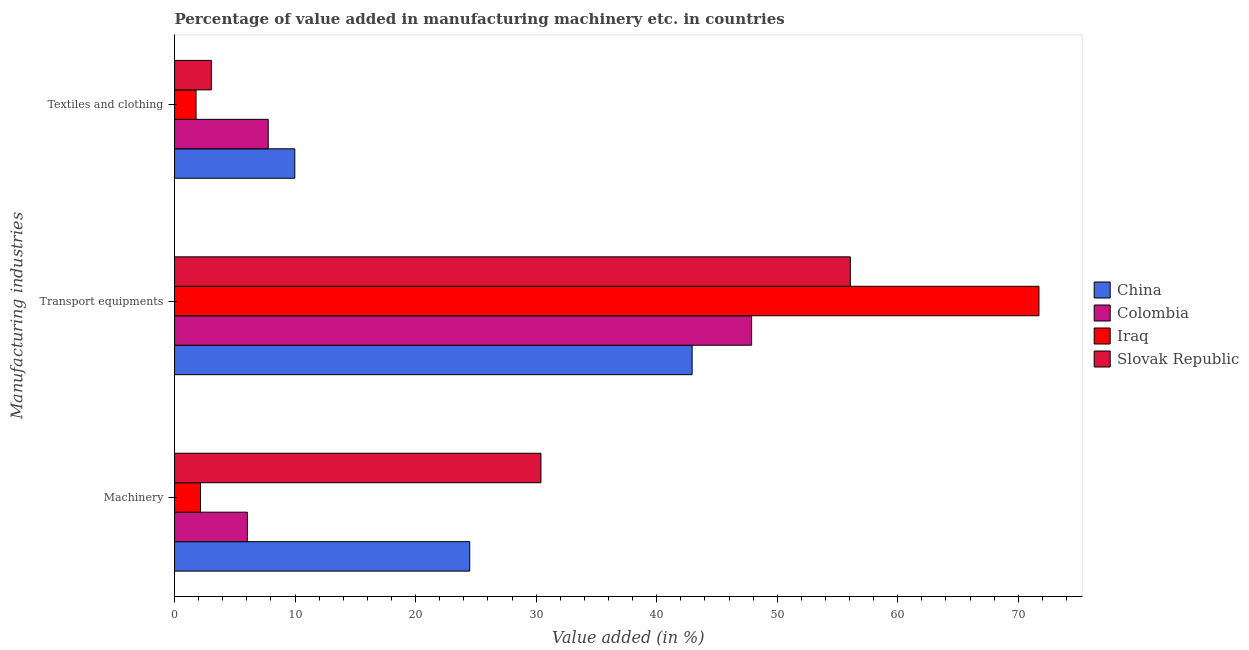How many groups of bars are there?
Your answer should be very brief. 3. Are the number of bars per tick equal to the number of legend labels?
Your answer should be very brief. Yes. How many bars are there on the 2nd tick from the top?
Your answer should be very brief. 4. How many bars are there on the 2nd tick from the bottom?
Your answer should be very brief. 4. What is the label of the 1st group of bars from the top?
Your response must be concise. Textiles and clothing. What is the value added in manufacturing textile and clothing in Iraq?
Keep it short and to the point. 1.78. Across all countries, what is the maximum value added in manufacturing textile and clothing?
Provide a succinct answer. 9.98. Across all countries, what is the minimum value added in manufacturing machinery?
Your response must be concise. 2.15. In which country was the value added in manufacturing textile and clothing maximum?
Give a very brief answer. China. In which country was the value added in manufacturing textile and clothing minimum?
Provide a succinct answer. Iraq. What is the total value added in manufacturing textile and clothing in the graph?
Your response must be concise. 22.58. What is the difference between the value added in manufacturing machinery in Iraq and that in China?
Offer a very short reply. -22.33. What is the difference between the value added in manufacturing machinery in China and the value added in manufacturing textile and clothing in Iraq?
Offer a terse response. 22.7. What is the average value added in manufacturing textile and clothing per country?
Your answer should be very brief. 5.65. What is the difference between the value added in manufacturing textile and clothing and value added in manufacturing transport equipments in China?
Your response must be concise. -32.96. In how many countries, is the value added in manufacturing machinery greater than 48 %?
Offer a terse response. 0. What is the ratio of the value added in manufacturing transport equipments in Slovak Republic to that in Colombia?
Keep it short and to the point. 1.17. Is the value added in manufacturing textile and clothing in Slovak Republic less than that in Iraq?
Give a very brief answer. No. What is the difference between the highest and the second highest value added in manufacturing transport equipments?
Provide a succinct answer. 15.65. What is the difference between the highest and the lowest value added in manufacturing machinery?
Provide a succinct answer. 28.24. In how many countries, is the value added in manufacturing textile and clothing greater than the average value added in manufacturing textile and clothing taken over all countries?
Give a very brief answer. 2. Is the sum of the value added in manufacturing textile and clothing in Iraq and China greater than the maximum value added in manufacturing machinery across all countries?
Give a very brief answer. No. What does the 1st bar from the top in Transport equipments represents?
Your answer should be very brief. Slovak Republic. How many bars are there?
Keep it short and to the point. 12. Are all the bars in the graph horizontal?
Ensure brevity in your answer.  Yes. What is the difference between two consecutive major ticks on the X-axis?
Your answer should be very brief. 10. Does the graph contain any zero values?
Provide a short and direct response. No. Does the graph contain grids?
Offer a very short reply. No. Where does the legend appear in the graph?
Offer a terse response. Center right. What is the title of the graph?
Offer a very short reply. Percentage of value added in manufacturing machinery etc. in countries. What is the label or title of the X-axis?
Keep it short and to the point. Value added (in %). What is the label or title of the Y-axis?
Your answer should be very brief. Manufacturing industries. What is the Value added (in %) in China in Machinery?
Give a very brief answer. 24.49. What is the Value added (in %) of Colombia in Machinery?
Your response must be concise. 6.04. What is the Value added (in %) in Iraq in Machinery?
Offer a very short reply. 2.15. What is the Value added (in %) in Slovak Republic in Machinery?
Your answer should be compact. 30.4. What is the Value added (in %) in China in Transport equipments?
Make the answer very short. 42.94. What is the Value added (in %) in Colombia in Transport equipments?
Your response must be concise. 47.88. What is the Value added (in %) in Iraq in Transport equipments?
Your answer should be very brief. 71.71. What is the Value added (in %) in Slovak Republic in Transport equipments?
Provide a succinct answer. 56.06. What is the Value added (in %) of China in Textiles and clothing?
Ensure brevity in your answer.  9.98. What is the Value added (in %) in Colombia in Textiles and clothing?
Keep it short and to the point. 7.77. What is the Value added (in %) in Iraq in Textiles and clothing?
Give a very brief answer. 1.78. What is the Value added (in %) of Slovak Republic in Textiles and clothing?
Offer a terse response. 3.05. Across all Manufacturing industries, what is the maximum Value added (in %) of China?
Provide a short and direct response. 42.94. Across all Manufacturing industries, what is the maximum Value added (in %) of Colombia?
Offer a very short reply. 47.88. Across all Manufacturing industries, what is the maximum Value added (in %) of Iraq?
Your response must be concise. 71.71. Across all Manufacturing industries, what is the maximum Value added (in %) in Slovak Republic?
Ensure brevity in your answer.  56.06. Across all Manufacturing industries, what is the minimum Value added (in %) in China?
Your response must be concise. 9.98. Across all Manufacturing industries, what is the minimum Value added (in %) of Colombia?
Give a very brief answer. 6.04. Across all Manufacturing industries, what is the minimum Value added (in %) of Iraq?
Offer a terse response. 1.78. Across all Manufacturing industries, what is the minimum Value added (in %) in Slovak Republic?
Your answer should be compact. 3.05. What is the total Value added (in %) in China in the graph?
Your answer should be compact. 77.4. What is the total Value added (in %) in Colombia in the graph?
Your response must be concise. 61.69. What is the total Value added (in %) in Iraq in the graph?
Your answer should be compact. 75.65. What is the total Value added (in %) in Slovak Republic in the graph?
Your response must be concise. 89.51. What is the difference between the Value added (in %) in China in Machinery and that in Transport equipments?
Ensure brevity in your answer.  -18.45. What is the difference between the Value added (in %) of Colombia in Machinery and that in Transport equipments?
Provide a short and direct response. -41.84. What is the difference between the Value added (in %) in Iraq in Machinery and that in Transport equipments?
Offer a very short reply. -69.56. What is the difference between the Value added (in %) in Slovak Republic in Machinery and that in Transport equipments?
Your answer should be very brief. -25.67. What is the difference between the Value added (in %) of China in Machinery and that in Textiles and clothing?
Give a very brief answer. 14.51. What is the difference between the Value added (in %) of Colombia in Machinery and that in Textiles and clothing?
Provide a short and direct response. -1.73. What is the difference between the Value added (in %) of Iraq in Machinery and that in Textiles and clothing?
Provide a short and direct response. 0.37. What is the difference between the Value added (in %) in Slovak Republic in Machinery and that in Textiles and clothing?
Give a very brief answer. 27.34. What is the difference between the Value added (in %) in China in Transport equipments and that in Textiles and clothing?
Make the answer very short. 32.96. What is the difference between the Value added (in %) of Colombia in Transport equipments and that in Textiles and clothing?
Offer a very short reply. 40.1. What is the difference between the Value added (in %) in Iraq in Transport equipments and that in Textiles and clothing?
Give a very brief answer. 69.93. What is the difference between the Value added (in %) in Slovak Republic in Transport equipments and that in Textiles and clothing?
Keep it short and to the point. 53.01. What is the difference between the Value added (in %) of China in Machinery and the Value added (in %) of Colombia in Transport equipments?
Keep it short and to the point. -23.39. What is the difference between the Value added (in %) of China in Machinery and the Value added (in %) of Iraq in Transport equipments?
Your answer should be very brief. -47.23. What is the difference between the Value added (in %) in China in Machinery and the Value added (in %) in Slovak Republic in Transport equipments?
Give a very brief answer. -31.58. What is the difference between the Value added (in %) of Colombia in Machinery and the Value added (in %) of Iraq in Transport equipments?
Ensure brevity in your answer.  -65.67. What is the difference between the Value added (in %) of Colombia in Machinery and the Value added (in %) of Slovak Republic in Transport equipments?
Offer a very short reply. -50.02. What is the difference between the Value added (in %) of Iraq in Machinery and the Value added (in %) of Slovak Republic in Transport equipments?
Ensure brevity in your answer.  -53.91. What is the difference between the Value added (in %) in China in Machinery and the Value added (in %) in Colombia in Textiles and clothing?
Offer a very short reply. 16.72. What is the difference between the Value added (in %) in China in Machinery and the Value added (in %) in Iraq in Textiles and clothing?
Provide a succinct answer. 22.7. What is the difference between the Value added (in %) in China in Machinery and the Value added (in %) in Slovak Republic in Textiles and clothing?
Your answer should be compact. 21.43. What is the difference between the Value added (in %) in Colombia in Machinery and the Value added (in %) in Iraq in Textiles and clothing?
Offer a very short reply. 4.26. What is the difference between the Value added (in %) in Colombia in Machinery and the Value added (in %) in Slovak Republic in Textiles and clothing?
Ensure brevity in your answer.  2.98. What is the difference between the Value added (in %) of Iraq in Machinery and the Value added (in %) of Slovak Republic in Textiles and clothing?
Your answer should be very brief. -0.9. What is the difference between the Value added (in %) of China in Transport equipments and the Value added (in %) of Colombia in Textiles and clothing?
Your answer should be compact. 35.17. What is the difference between the Value added (in %) in China in Transport equipments and the Value added (in %) in Iraq in Textiles and clothing?
Your response must be concise. 41.16. What is the difference between the Value added (in %) of China in Transport equipments and the Value added (in %) of Slovak Republic in Textiles and clothing?
Offer a very short reply. 39.88. What is the difference between the Value added (in %) of Colombia in Transport equipments and the Value added (in %) of Iraq in Textiles and clothing?
Give a very brief answer. 46.09. What is the difference between the Value added (in %) in Colombia in Transport equipments and the Value added (in %) in Slovak Republic in Textiles and clothing?
Your answer should be very brief. 44.82. What is the difference between the Value added (in %) in Iraq in Transport equipments and the Value added (in %) in Slovak Republic in Textiles and clothing?
Give a very brief answer. 68.66. What is the average Value added (in %) of China per Manufacturing industries?
Make the answer very short. 25.8. What is the average Value added (in %) of Colombia per Manufacturing industries?
Offer a very short reply. 20.56. What is the average Value added (in %) of Iraq per Manufacturing industries?
Provide a succinct answer. 25.22. What is the average Value added (in %) of Slovak Republic per Manufacturing industries?
Ensure brevity in your answer.  29.84. What is the difference between the Value added (in %) in China and Value added (in %) in Colombia in Machinery?
Your response must be concise. 18.45. What is the difference between the Value added (in %) of China and Value added (in %) of Iraq in Machinery?
Make the answer very short. 22.33. What is the difference between the Value added (in %) of China and Value added (in %) of Slovak Republic in Machinery?
Offer a very short reply. -5.91. What is the difference between the Value added (in %) in Colombia and Value added (in %) in Iraq in Machinery?
Your response must be concise. 3.89. What is the difference between the Value added (in %) of Colombia and Value added (in %) of Slovak Republic in Machinery?
Give a very brief answer. -24.36. What is the difference between the Value added (in %) of Iraq and Value added (in %) of Slovak Republic in Machinery?
Provide a succinct answer. -28.24. What is the difference between the Value added (in %) of China and Value added (in %) of Colombia in Transport equipments?
Provide a short and direct response. -4.94. What is the difference between the Value added (in %) of China and Value added (in %) of Iraq in Transport equipments?
Make the answer very short. -28.77. What is the difference between the Value added (in %) in China and Value added (in %) in Slovak Republic in Transport equipments?
Your answer should be compact. -13.12. What is the difference between the Value added (in %) in Colombia and Value added (in %) in Iraq in Transport equipments?
Ensure brevity in your answer.  -23.84. What is the difference between the Value added (in %) in Colombia and Value added (in %) in Slovak Republic in Transport equipments?
Offer a terse response. -8.19. What is the difference between the Value added (in %) in Iraq and Value added (in %) in Slovak Republic in Transport equipments?
Offer a very short reply. 15.65. What is the difference between the Value added (in %) in China and Value added (in %) in Colombia in Textiles and clothing?
Provide a succinct answer. 2.2. What is the difference between the Value added (in %) in China and Value added (in %) in Iraq in Textiles and clothing?
Your answer should be compact. 8.19. What is the difference between the Value added (in %) of China and Value added (in %) of Slovak Republic in Textiles and clothing?
Give a very brief answer. 6.92. What is the difference between the Value added (in %) of Colombia and Value added (in %) of Iraq in Textiles and clothing?
Provide a short and direct response. 5.99. What is the difference between the Value added (in %) in Colombia and Value added (in %) in Slovak Republic in Textiles and clothing?
Your answer should be compact. 4.72. What is the difference between the Value added (in %) of Iraq and Value added (in %) of Slovak Republic in Textiles and clothing?
Make the answer very short. -1.27. What is the ratio of the Value added (in %) of China in Machinery to that in Transport equipments?
Provide a succinct answer. 0.57. What is the ratio of the Value added (in %) in Colombia in Machinery to that in Transport equipments?
Offer a very short reply. 0.13. What is the ratio of the Value added (in %) of Iraq in Machinery to that in Transport equipments?
Your answer should be very brief. 0.03. What is the ratio of the Value added (in %) of Slovak Republic in Machinery to that in Transport equipments?
Give a very brief answer. 0.54. What is the ratio of the Value added (in %) in China in Machinery to that in Textiles and clothing?
Your answer should be very brief. 2.45. What is the ratio of the Value added (in %) in Colombia in Machinery to that in Textiles and clothing?
Make the answer very short. 0.78. What is the ratio of the Value added (in %) in Iraq in Machinery to that in Textiles and clothing?
Offer a terse response. 1.21. What is the ratio of the Value added (in %) in Slovak Republic in Machinery to that in Textiles and clothing?
Ensure brevity in your answer.  9.95. What is the ratio of the Value added (in %) of China in Transport equipments to that in Textiles and clothing?
Keep it short and to the point. 4.3. What is the ratio of the Value added (in %) in Colombia in Transport equipments to that in Textiles and clothing?
Offer a terse response. 6.16. What is the ratio of the Value added (in %) in Iraq in Transport equipments to that in Textiles and clothing?
Your answer should be compact. 40.22. What is the ratio of the Value added (in %) in Slovak Republic in Transport equipments to that in Textiles and clothing?
Provide a succinct answer. 18.35. What is the difference between the highest and the second highest Value added (in %) of China?
Give a very brief answer. 18.45. What is the difference between the highest and the second highest Value added (in %) of Colombia?
Make the answer very short. 40.1. What is the difference between the highest and the second highest Value added (in %) in Iraq?
Keep it short and to the point. 69.56. What is the difference between the highest and the second highest Value added (in %) of Slovak Republic?
Your answer should be very brief. 25.67. What is the difference between the highest and the lowest Value added (in %) in China?
Give a very brief answer. 32.96. What is the difference between the highest and the lowest Value added (in %) of Colombia?
Your response must be concise. 41.84. What is the difference between the highest and the lowest Value added (in %) of Iraq?
Your answer should be compact. 69.93. What is the difference between the highest and the lowest Value added (in %) in Slovak Republic?
Make the answer very short. 53.01. 